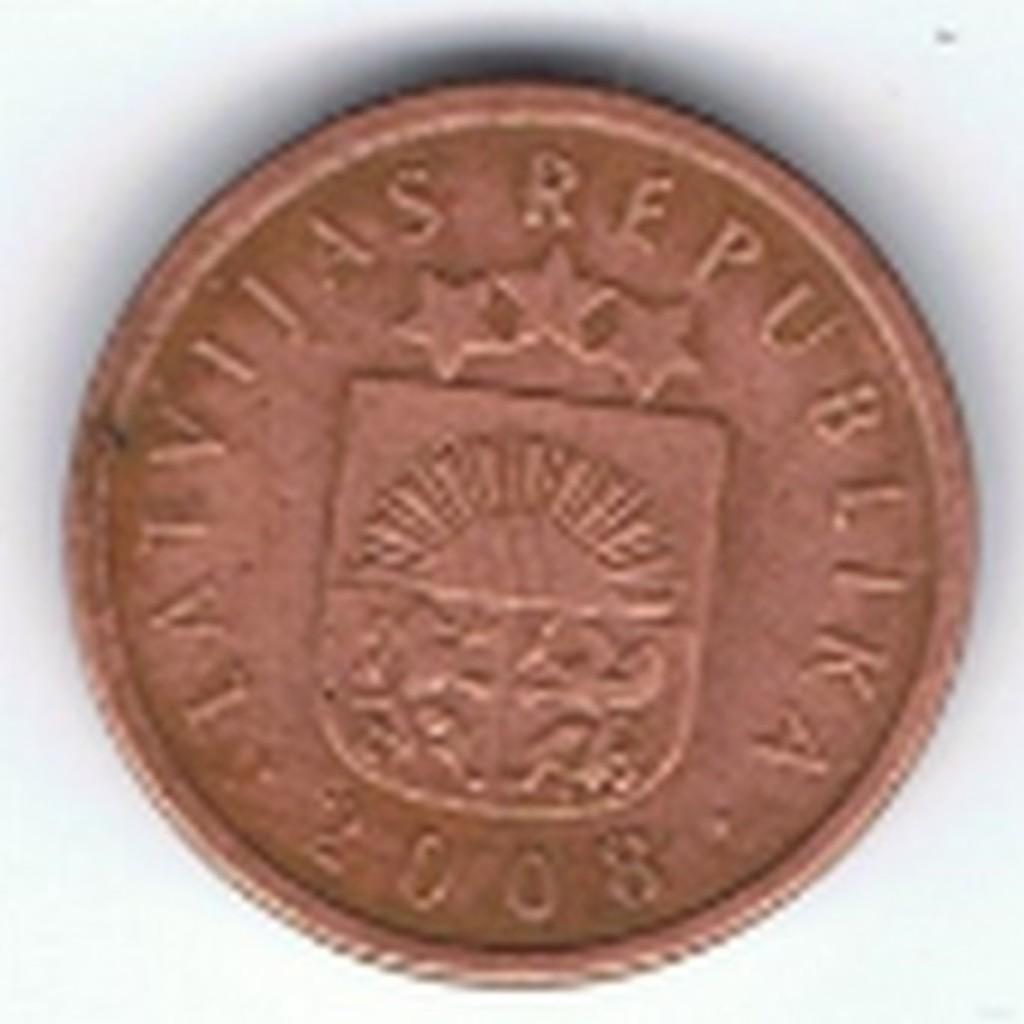<image>
Present a compact description of the photo's key features. A 2008 bronze coin from Latvilas Republika with 2 lions and 3 stars as the symbol. 